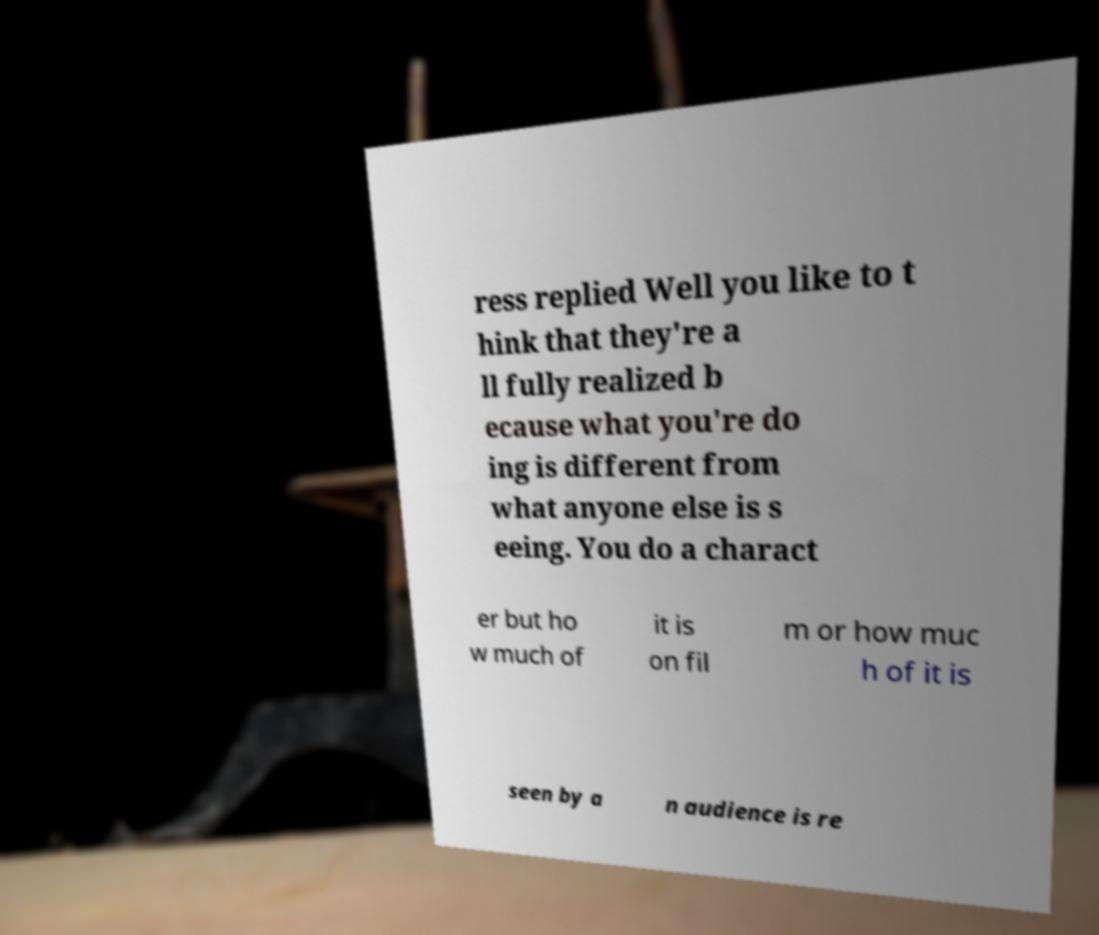There's text embedded in this image that I need extracted. Can you transcribe it verbatim? ress replied Well you like to t hink that they're a ll fully realized b ecause what you're do ing is different from what anyone else is s eeing. You do a charact er but ho w much of it is on fil m or how muc h of it is seen by a n audience is re 